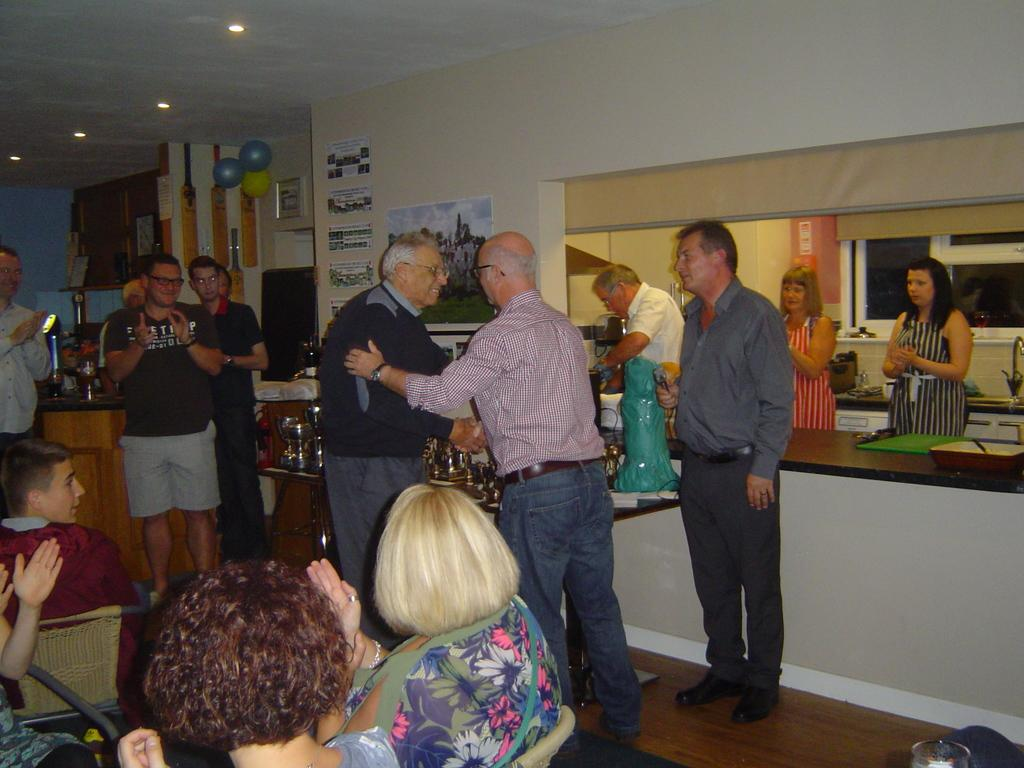What are the two old men doing in the middle of the image? The two old men are shaking hands in the middle of the image. What can be seen on the right side of the image? There are two women standing on the right side of the image. What is happening on the left side of the image? There are people sitting on chairs on the left side of the image. Is there a volcano erupting in the background of the image? There is no volcano present in the image. What type of peace symbol can be seen in the image? There is no peace symbol present in the image. 